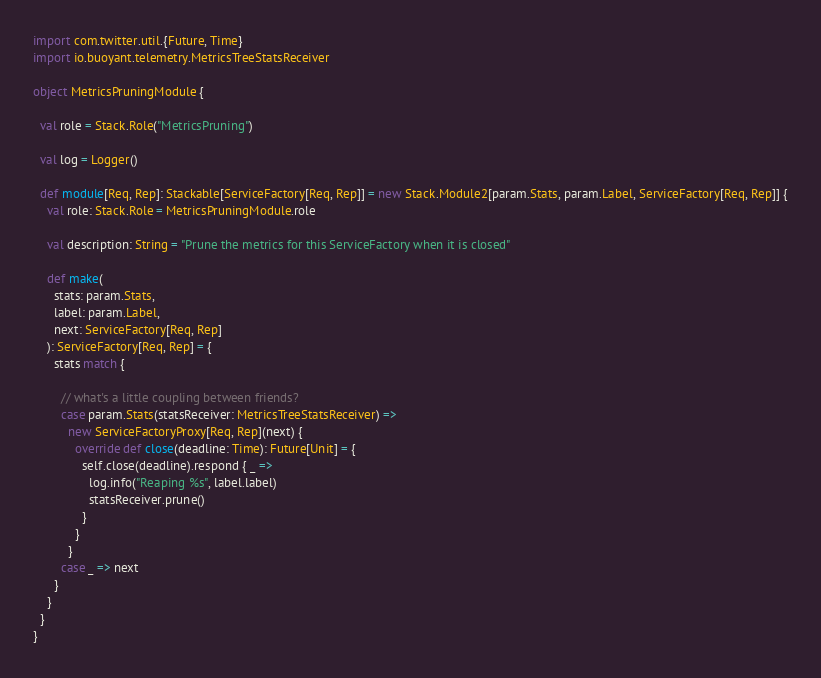Convert code to text. <code><loc_0><loc_0><loc_500><loc_500><_Scala_>import com.twitter.util.{Future, Time}
import io.buoyant.telemetry.MetricsTreeStatsReceiver

object MetricsPruningModule {

  val role = Stack.Role("MetricsPruning")

  val log = Logger()

  def module[Req, Rep]: Stackable[ServiceFactory[Req, Rep]] = new Stack.Module2[param.Stats, param.Label, ServiceFactory[Req, Rep]] {
    val role: Stack.Role = MetricsPruningModule.role

    val description: String = "Prune the metrics for this ServiceFactory when it is closed"

    def make(
      stats: param.Stats,
      label: param.Label,
      next: ServiceFactory[Req, Rep]
    ): ServiceFactory[Req, Rep] = {
      stats match {

        // what's a little coupling between friends?
        case param.Stats(statsReceiver: MetricsTreeStatsReceiver) =>
          new ServiceFactoryProxy[Req, Rep](next) {
            override def close(deadline: Time): Future[Unit] = {
              self.close(deadline).respond { _ =>
                log.info("Reaping %s", label.label)
                statsReceiver.prune()
              }
            }
          }
        case _ => next
      }
    }
  }
}</code> 